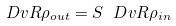Convert formula to latex. <formula><loc_0><loc_0><loc_500><loc_500>\ D v R { \rho _ { o u t } } = S \ D v R { \rho _ { i n } }</formula> 